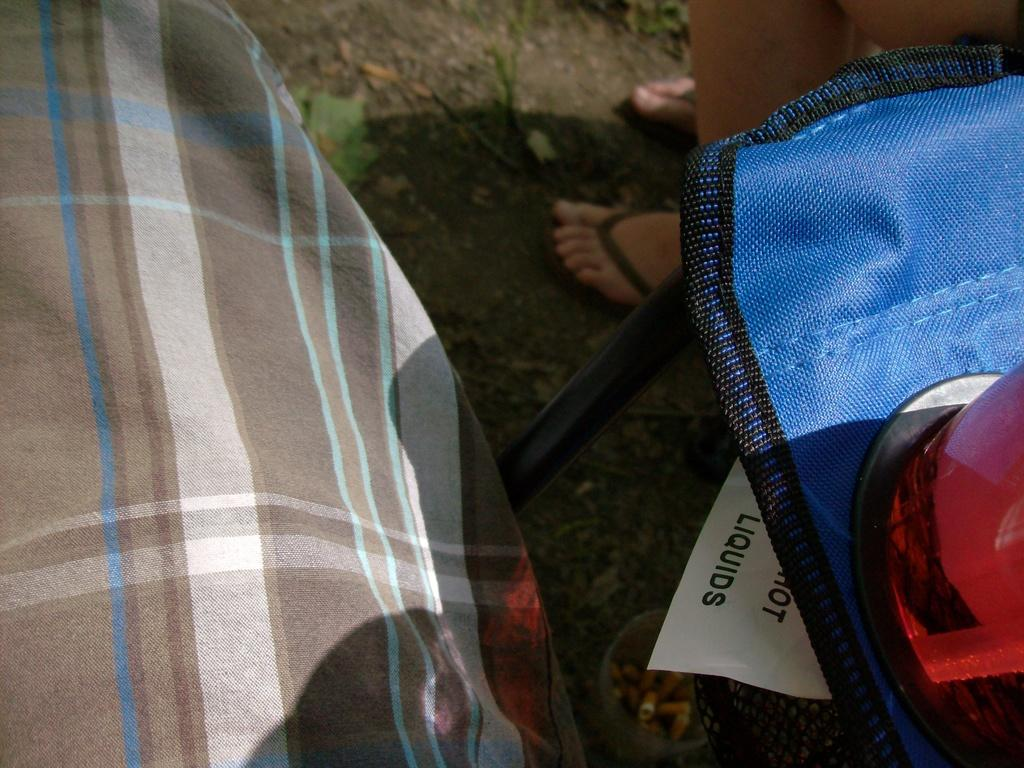What body part can be seen in the image? The image contains legs of a person. What type of object is also present in the image? There is a vehicle in the image. Can you describe the light source in the image? Yes, there is a light source in the image. What is the nature of the object at the top of the image? A box is present in the image, along with soil and grass. Is there any vegetation in the image? Yes, there is a plant in the image. What can be inferred about the weather based on the image? The image appears to be taken on a sunny day. How many visitors can be seen in the image? There is no visitor present in the image; it only contains legs of a person, a vehicle, a light source, a box, soil, grass, and a plant. What type of animal is sitting on the person's shoulder in the image? There is no animal, such as an owl, present in the image. 